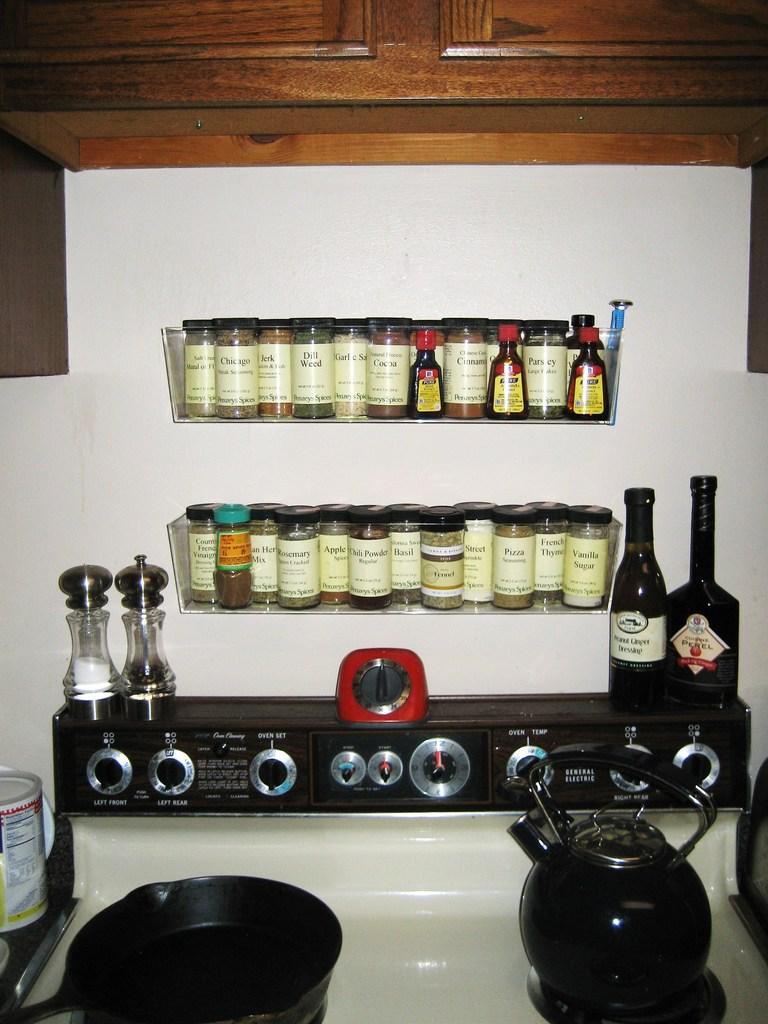What kind of herb is the green glass on the top rack?
Give a very brief answer. Unanswerable. 